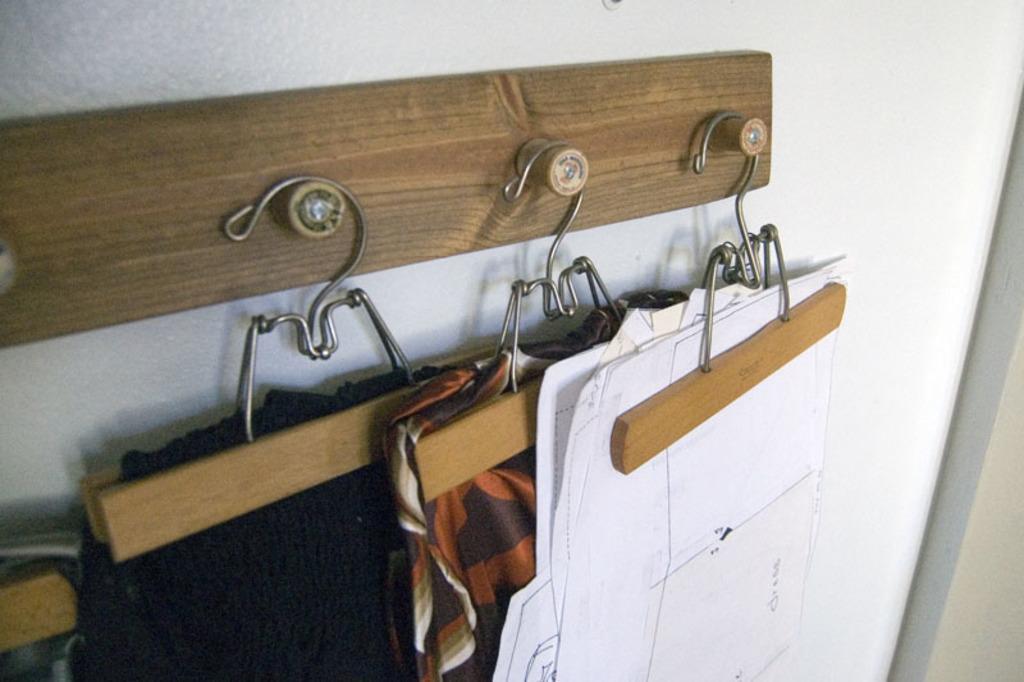Describe this image in one or two sentences. In this image we can see some clothes and papers on hangers placed on a wooden board. 